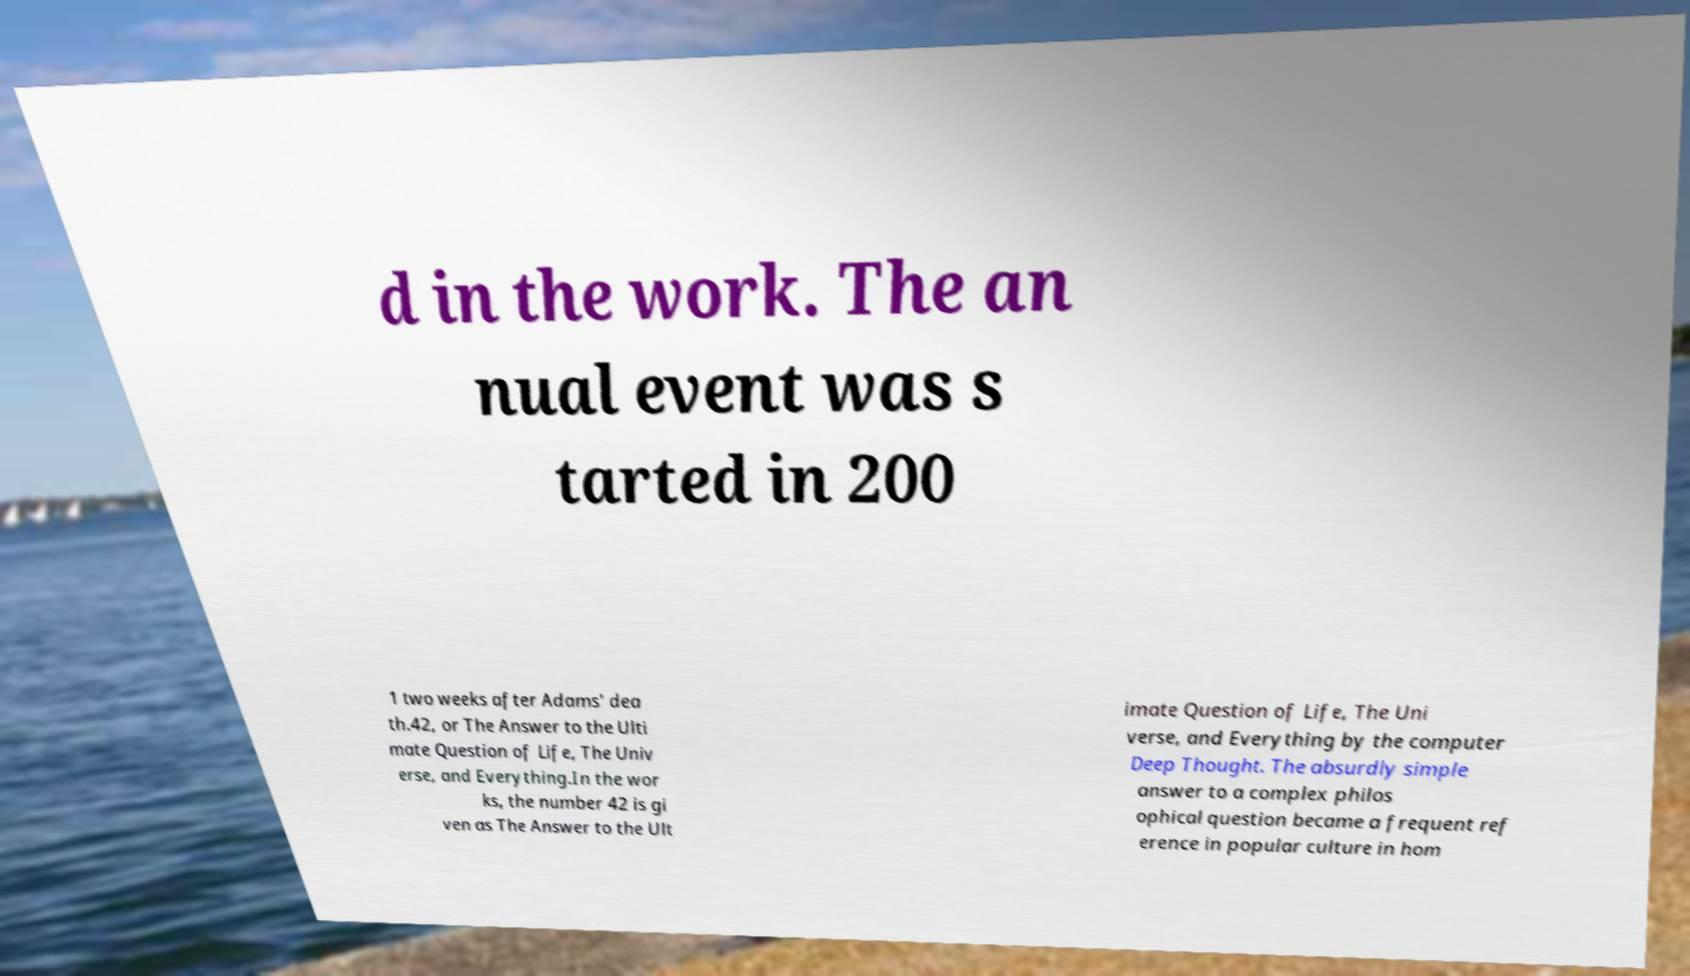Could you assist in decoding the text presented in this image and type it out clearly? d in the work. The an nual event was s tarted in 200 1 two weeks after Adams' dea th.42, or The Answer to the Ulti mate Question of Life, The Univ erse, and Everything.In the wor ks, the number 42 is gi ven as The Answer to the Ult imate Question of Life, The Uni verse, and Everything by the computer Deep Thought. The absurdly simple answer to a complex philos ophical question became a frequent ref erence in popular culture in hom 